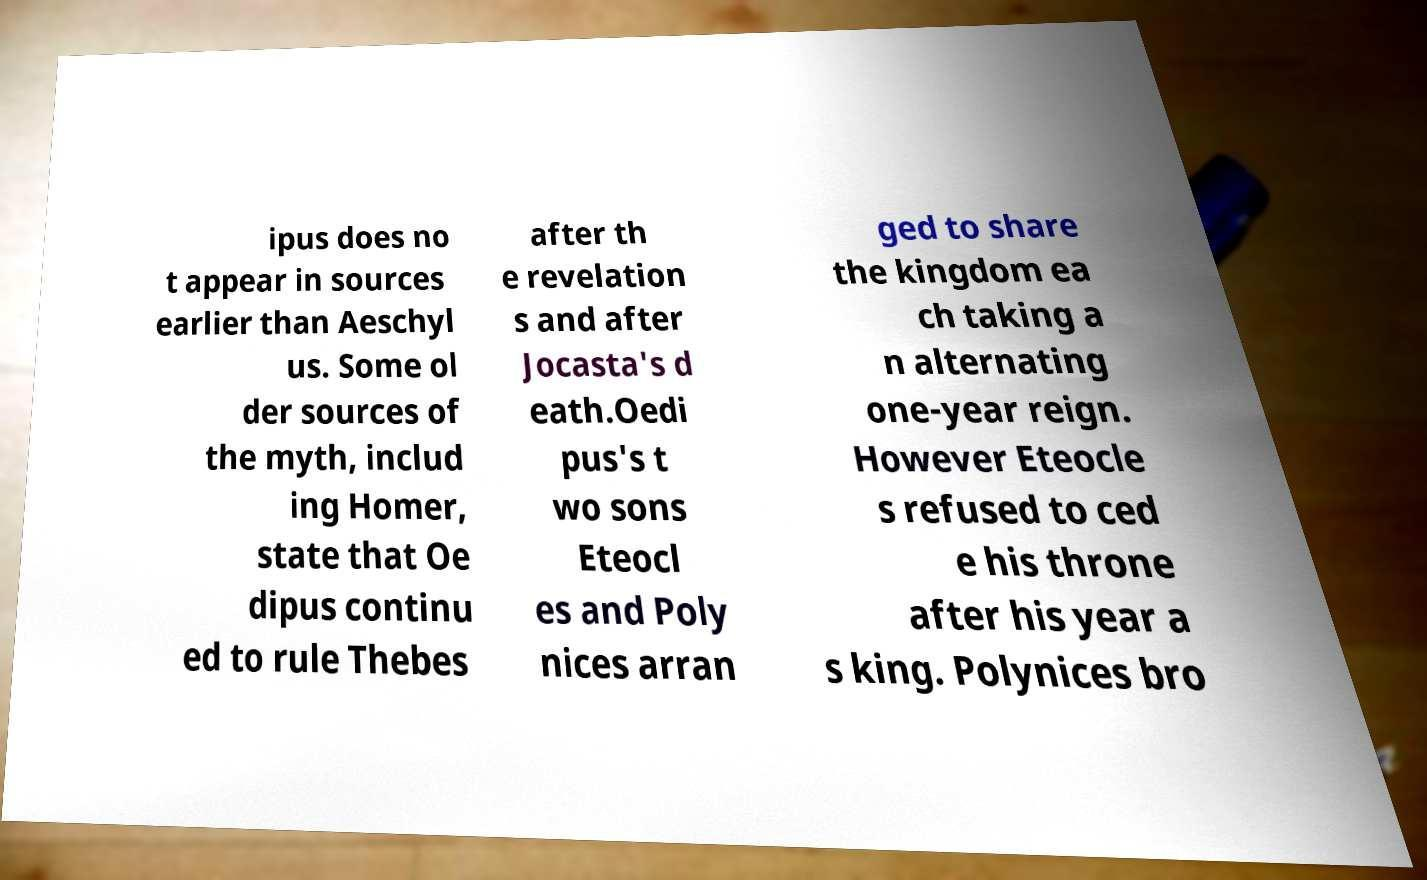Please read and relay the text visible in this image. What does it say? ipus does no t appear in sources earlier than Aeschyl us. Some ol der sources of the myth, includ ing Homer, state that Oe dipus continu ed to rule Thebes after th e revelation s and after Jocasta's d eath.Oedi pus's t wo sons Eteocl es and Poly nices arran ged to share the kingdom ea ch taking a n alternating one-year reign. However Eteocle s refused to ced e his throne after his year a s king. Polynices bro 